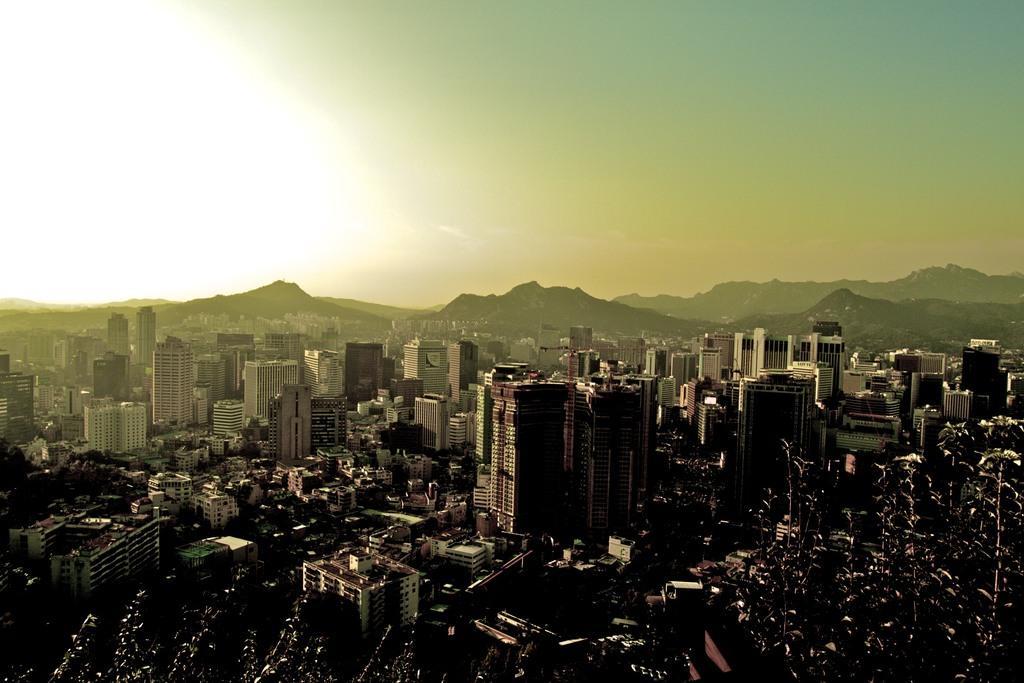Describe this image in one or two sentences. This is an aerial view, in this image there are trees, buildings, houses, mountains and the sky. 